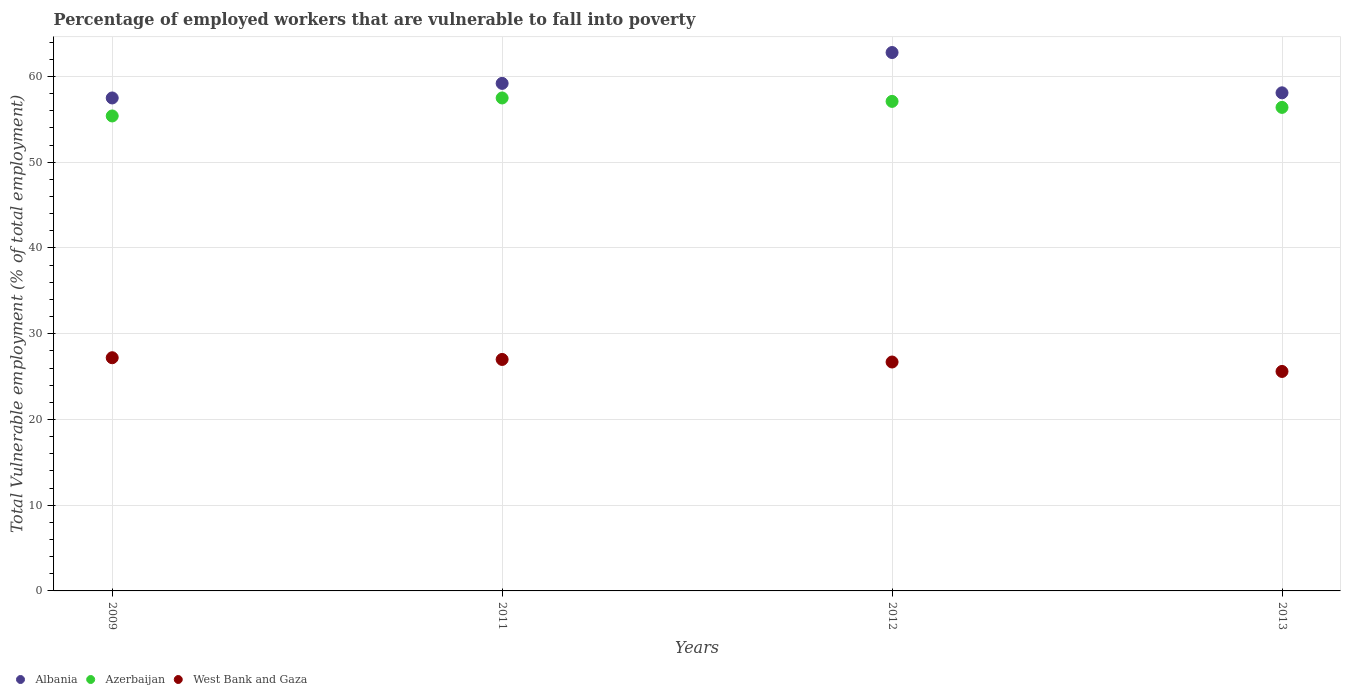How many different coloured dotlines are there?
Keep it short and to the point. 3. What is the percentage of employed workers who are vulnerable to fall into poverty in Albania in 2012?
Make the answer very short. 62.8. Across all years, what is the maximum percentage of employed workers who are vulnerable to fall into poverty in West Bank and Gaza?
Give a very brief answer. 27.2. Across all years, what is the minimum percentage of employed workers who are vulnerable to fall into poverty in West Bank and Gaza?
Your answer should be compact. 25.6. What is the total percentage of employed workers who are vulnerable to fall into poverty in Azerbaijan in the graph?
Give a very brief answer. 226.4. What is the difference between the percentage of employed workers who are vulnerable to fall into poverty in Azerbaijan in 2009 and that in 2011?
Offer a very short reply. -2.1. What is the difference between the percentage of employed workers who are vulnerable to fall into poverty in West Bank and Gaza in 2011 and the percentage of employed workers who are vulnerable to fall into poverty in Azerbaijan in 2012?
Ensure brevity in your answer.  -30.1. What is the average percentage of employed workers who are vulnerable to fall into poverty in Albania per year?
Keep it short and to the point. 59.4. In the year 2013, what is the difference between the percentage of employed workers who are vulnerable to fall into poverty in West Bank and Gaza and percentage of employed workers who are vulnerable to fall into poverty in Albania?
Provide a short and direct response. -32.5. What is the ratio of the percentage of employed workers who are vulnerable to fall into poverty in Azerbaijan in 2011 to that in 2013?
Make the answer very short. 1.02. Is the difference between the percentage of employed workers who are vulnerable to fall into poverty in West Bank and Gaza in 2011 and 2012 greater than the difference between the percentage of employed workers who are vulnerable to fall into poverty in Albania in 2011 and 2012?
Provide a succinct answer. Yes. What is the difference between the highest and the second highest percentage of employed workers who are vulnerable to fall into poverty in Azerbaijan?
Your answer should be very brief. 0.4. What is the difference between the highest and the lowest percentage of employed workers who are vulnerable to fall into poverty in Albania?
Offer a very short reply. 5.3. In how many years, is the percentage of employed workers who are vulnerable to fall into poverty in Azerbaijan greater than the average percentage of employed workers who are vulnerable to fall into poverty in Azerbaijan taken over all years?
Offer a very short reply. 2. Is it the case that in every year, the sum of the percentage of employed workers who are vulnerable to fall into poverty in Azerbaijan and percentage of employed workers who are vulnerable to fall into poverty in Albania  is greater than the percentage of employed workers who are vulnerable to fall into poverty in West Bank and Gaza?
Keep it short and to the point. Yes. Does the percentage of employed workers who are vulnerable to fall into poverty in West Bank and Gaza monotonically increase over the years?
Offer a terse response. No. How many years are there in the graph?
Offer a very short reply. 4. Does the graph contain any zero values?
Give a very brief answer. No. Does the graph contain grids?
Your answer should be compact. Yes. How are the legend labels stacked?
Provide a succinct answer. Horizontal. What is the title of the graph?
Provide a succinct answer. Percentage of employed workers that are vulnerable to fall into poverty. Does "Sudan" appear as one of the legend labels in the graph?
Ensure brevity in your answer.  No. What is the label or title of the Y-axis?
Offer a terse response. Total Vulnerable employment (% of total employment). What is the Total Vulnerable employment (% of total employment) of Albania in 2009?
Your answer should be very brief. 57.5. What is the Total Vulnerable employment (% of total employment) in Azerbaijan in 2009?
Your response must be concise. 55.4. What is the Total Vulnerable employment (% of total employment) of West Bank and Gaza in 2009?
Ensure brevity in your answer.  27.2. What is the Total Vulnerable employment (% of total employment) in Albania in 2011?
Your answer should be very brief. 59.2. What is the Total Vulnerable employment (% of total employment) of Azerbaijan in 2011?
Your response must be concise. 57.5. What is the Total Vulnerable employment (% of total employment) in West Bank and Gaza in 2011?
Make the answer very short. 27. What is the Total Vulnerable employment (% of total employment) in Albania in 2012?
Your response must be concise. 62.8. What is the Total Vulnerable employment (% of total employment) in Azerbaijan in 2012?
Provide a succinct answer. 57.1. What is the Total Vulnerable employment (% of total employment) of West Bank and Gaza in 2012?
Offer a very short reply. 26.7. What is the Total Vulnerable employment (% of total employment) in Albania in 2013?
Provide a short and direct response. 58.1. What is the Total Vulnerable employment (% of total employment) in Azerbaijan in 2013?
Keep it short and to the point. 56.4. What is the Total Vulnerable employment (% of total employment) in West Bank and Gaza in 2013?
Your answer should be compact. 25.6. Across all years, what is the maximum Total Vulnerable employment (% of total employment) of Albania?
Your response must be concise. 62.8. Across all years, what is the maximum Total Vulnerable employment (% of total employment) in Azerbaijan?
Provide a succinct answer. 57.5. Across all years, what is the maximum Total Vulnerable employment (% of total employment) in West Bank and Gaza?
Provide a short and direct response. 27.2. Across all years, what is the minimum Total Vulnerable employment (% of total employment) of Albania?
Keep it short and to the point. 57.5. Across all years, what is the minimum Total Vulnerable employment (% of total employment) of Azerbaijan?
Ensure brevity in your answer.  55.4. Across all years, what is the minimum Total Vulnerable employment (% of total employment) in West Bank and Gaza?
Your answer should be compact. 25.6. What is the total Total Vulnerable employment (% of total employment) in Albania in the graph?
Your response must be concise. 237.6. What is the total Total Vulnerable employment (% of total employment) in Azerbaijan in the graph?
Give a very brief answer. 226.4. What is the total Total Vulnerable employment (% of total employment) in West Bank and Gaza in the graph?
Your response must be concise. 106.5. What is the difference between the Total Vulnerable employment (% of total employment) in Albania in 2009 and that in 2011?
Your answer should be compact. -1.7. What is the difference between the Total Vulnerable employment (% of total employment) of West Bank and Gaza in 2009 and that in 2011?
Give a very brief answer. 0.2. What is the difference between the Total Vulnerable employment (% of total employment) in Albania in 2009 and that in 2012?
Keep it short and to the point. -5.3. What is the difference between the Total Vulnerable employment (% of total employment) of Azerbaijan in 2009 and that in 2012?
Provide a succinct answer. -1.7. What is the difference between the Total Vulnerable employment (% of total employment) of West Bank and Gaza in 2009 and that in 2012?
Provide a succinct answer. 0.5. What is the difference between the Total Vulnerable employment (% of total employment) of Azerbaijan in 2011 and that in 2012?
Keep it short and to the point. 0.4. What is the difference between the Total Vulnerable employment (% of total employment) in Azerbaijan in 2011 and that in 2013?
Ensure brevity in your answer.  1.1. What is the difference between the Total Vulnerable employment (% of total employment) of West Bank and Gaza in 2011 and that in 2013?
Offer a very short reply. 1.4. What is the difference between the Total Vulnerable employment (% of total employment) in Azerbaijan in 2012 and that in 2013?
Your answer should be very brief. 0.7. What is the difference between the Total Vulnerable employment (% of total employment) of Albania in 2009 and the Total Vulnerable employment (% of total employment) of West Bank and Gaza in 2011?
Offer a terse response. 30.5. What is the difference between the Total Vulnerable employment (% of total employment) of Azerbaijan in 2009 and the Total Vulnerable employment (% of total employment) of West Bank and Gaza in 2011?
Offer a very short reply. 28.4. What is the difference between the Total Vulnerable employment (% of total employment) in Albania in 2009 and the Total Vulnerable employment (% of total employment) in Azerbaijan in 2012?
Provide a short and direct response. 0.4. What is the difference between the Total Vulnerable employment (% of total employment) of Albania in 2009 and the Total Vulnerable employment (% of total employment) of West Bank and Gaza in 2012?
Give a very brief answer. 30.8. What is the difference between the Total Vulnerable employment (% of total employment) in Azerbaijan in 2009 and the Total Vulnerable employment (% of total employment) in West Bank and Gaza in 2012?
Your answer should be compact. 28.7. What is the difference between the Total Vulnerable employment (% of total employment) in Albania in 2009 and the Total Vulnerable employment (% of total employment) in West Bank and Gaza in 2013?
Make the answer very short. 31.9. What is the difference between the Total Vulnerable employment (% of total employment) of Azerbaijan in 2009 and the Total Vulnerable employment (% of total employment) of West Bank and Gaza in 2013?
Ensure brevity in your answer.  29.8. What is the difference between the Total Vulnerable employment (% of total employment) of Albania in 2011 and the Total Vulnerable employment (% of total employment) of West Bank and Gaza in 2012?
Your answer should be very brief. 32.5. What is the difference between the Total Vulnerable employment (% of total employment) of Azerbaijan in 2011 and the Total Vulnerable employment (% of total employment) of West Bank and Gaza in 2012?
Your answer should be compact. 30.8. What is the difference between the Total Vulnerable employment (% of total employment) of Albania in 2011 and the Total Vulnerable employment (% of total employment) of West Bank and Gaza in 2013?
Your answer should be very brief. 33.6. What is the difference between the Total Vulnerable employment (% of total employment) in Azerbaijan in 2011 and the Total Vulnerable employment (% of total employment) in West Bank and Gaza in 2013?
Provide a short and direct response. 31.9. What is the difference between the Total Vulnerable employment (% of total employment) in Albania in 2012 and the Total Vulnerable employment (% of total employment) in West Bank and Gaza in 2013?
Make the answer very short. 37.2. What is the difference between the Total Vulnerable employment (% of total employment) of Azerbaijan in 2012 and the Total Vulnerable employment (% of total employment) of West Bank and Gaza in 2013?
Your response must be concise. 31.5. What is the average Total Vulnerable employment (% of total employment) in Albania per year?
Ensure brevity in your answer.  59.4. What is the average Total Vulnerable employment (% of total employment) in Azerbaijan per year?
Your response must be concise. 56.6. What is the average Total Vulnerable employment (% of total employment) in West Bank and Gaza per year?
Your answer should be very brief. 26.62. In the year 2009, what is the difference between the Total Vulnerable employment (% of total employment) in Albania and Total Vulnerable employment (% of total employment) in Azerbaijan?
Your response must be concise. 2.1. In the year 2009, what is the difference between the Total Vulnerable employment (% of total employment) in Albania and Total Vulnerable employment (% of total employment) in West Bank and Gaza?
Your answer should be compact. 30.3. In the year 2009, what is the difference between the Total Vulnerable employment (% of total employment) in Azerbaijan and Total Vulnerable employment (% of total employment) in West Bank and Gaza?
Provide a short and direct response. 28.2. In the year 2011, what is the difference between the Total Vulnerable employment (% of total employment) in Albania and Total Vulnerable employment (% of total employment) in Azerbaijan?
Your response must be concise. 1.7. In the year 2011, what is the difference between the Total Vulnerable employment (% of total employment) in Albania and Total Vulnerable employment (% of total employment) in West Bank and Gaza?
Offer a terse response. 32.2. In the year 2011, what is the difference between the Total Vulnerable employment (% of total employment) in Azerbaijan and Total Vulnerable employment (% of total employment) in West Bank and Gaza?
Give a very brief answer. 30.5. In the year 2012, what is the difference between the Total Vulnerable employment (% of total employment) of Albania and Total Vulnerable employment (% of total employment) of Azerbaijan?
Your answer should be very brief. 5.7. In the year 2012, what is the difference between the Total Vulnerable employment (% of total employment) of Albania and Total Vulnerable employment (% of total employment) of West Bank and Gaza?
Your answer should be compact. 36.1. In the year 2012, what is the difference between the Total Vulnerable employment (% of total employment) in Azerbaijan and Total Vulnerable employment (% of total employment) in West Bank and Gaza?
Offer a very short reply. 30.4. In the year 2013, what is the difference between the Total Vulnerable employment (% of total employment) in Albania and Total Vulnerable employment (% of total employment) in Azerbaijan?
Your answer should be compact. 1.7. In the year 2013, what is the difference between the Total Vulnerable employment (% of total employment) of Albania and Total Vulnerable employment (% of total employment) of West Bank and Gaza?
Your answer should be compact. 32.5. In the year 2013, what is the difference between the Total Vulnerable employment (% of total employment) of Azerbaijan and Total Vulnerable employment (% of total employment) of West Bank and Gaza?
Your answer should be compact. 30.8. What is the ratio of the Total Vulnerable employment (% of total employment) in Albania in 2009 to that in 2011?
Ensure brevity in your answer.  0.97. What is the ratio of the Total Vulnerable employment (% of total employment) of Azerbaijan in 2009 to that in 2011?
Give a very brief answer. 0.96. What is the ratio of the Total Vulnerable employment (% of total employment) of West Bank and Gaza in 2009 to that in 2011?
Keep it short and to the point. 1.01. What is the ratio of the Total Vulnerable employment (% of total employment) in Albania in 2009 to that in 2012?
Offer a terse response. 0.92. What is the ratio of the Total Vulnerable employment (% of total employment) of Azerbaijan in 2009 to that in 2012?
Your response must be concise. 0.97. What is the ratio of the Total Vulnerable employment (% of total employment) in West Bank and Gaza in 2009 to that in 2012?
Provide a succinct answer. 1.02. What is the ratio of the Total Vulnerable employment (% of total employment) in Albania in 2009 to that in 2013?
Provide a succinct answer. 0.99. What is the ratio of the Total Vulnerable employment (% of total employment) in Azerbaijan in 2009 to that in 2013?
Offer a very short reply. 0.98. What is the ratio of the Total Vulnerable employment (% of total employment) of Albania in 2011 to that in 2012?
Provide a succinct answer. 0.94. What is the ratio of the Total Vulnerable employment (% of total employment) in West Bank and Gaza in 2011 to that in 2012?
Your answer should be compact. 1.01. What is the ratio of the Total Vulnerable employment (% of total employment) in Albania in 2011 to that in 2013?
Make the answer very short. 1.02. What is the ratio of the Total Vulnerable employment (% of total employment) of Azerbaijan in 2011 to that in 2013?
Offer a very short reply. 1.02. What is the ratio of the Total Vulnerable employment (% of total employment) of West Bank and Gaza in 2011 to that in 2013?
Ensure brevity in your answer.  1.05. What is the ratio of the Total Vulnerable employment (% of total employment) in Albania in 2012 to that in 2013?
Your answer should be very brief. 1.08. What is the ratio of the Total Vulnerable employment (% of total employment) of Azerbaijan in 2012 to that in 2013?
Offer a terse response. 1.01. What is the ratio of the Total Vulnerable employment (% of total employment) of West Bank and Gaza in 2012 to that in 2013?
Keep it short and to the point. 1.04. What is the difference between the highest and the second highest Total Vulnerable employment (% of total employment) in Albania?
Offer a terse response. 3.6. What is the difference between the highest and the second highest Total Vulnerable employment (% of total employment) in West Bank and Gaza?
Provide a short and direct response. 0.2. What is the difference between the highest and the lowest Total Vulnerable employment (% of total employment) of Azerbaijan?
Make the answer very short. 2.1. 